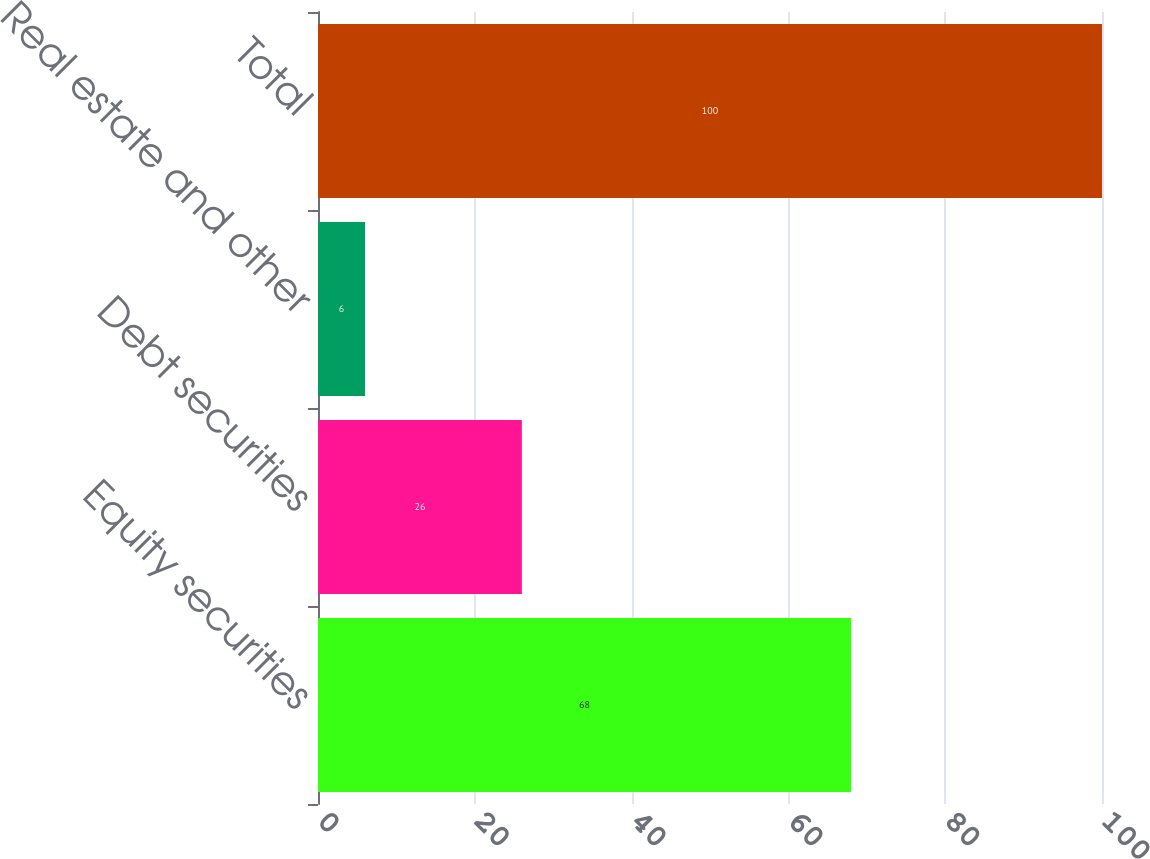<chart> <loc_0><loc_0><loc_500><loc_500><bar_chart><fcel>Equity securities<fcel>Debt securities<fcel>Real estate and other<fcel>Total<nl><fcel>68<fcel>26<fcel>6<fcel>100<nl></chart> 